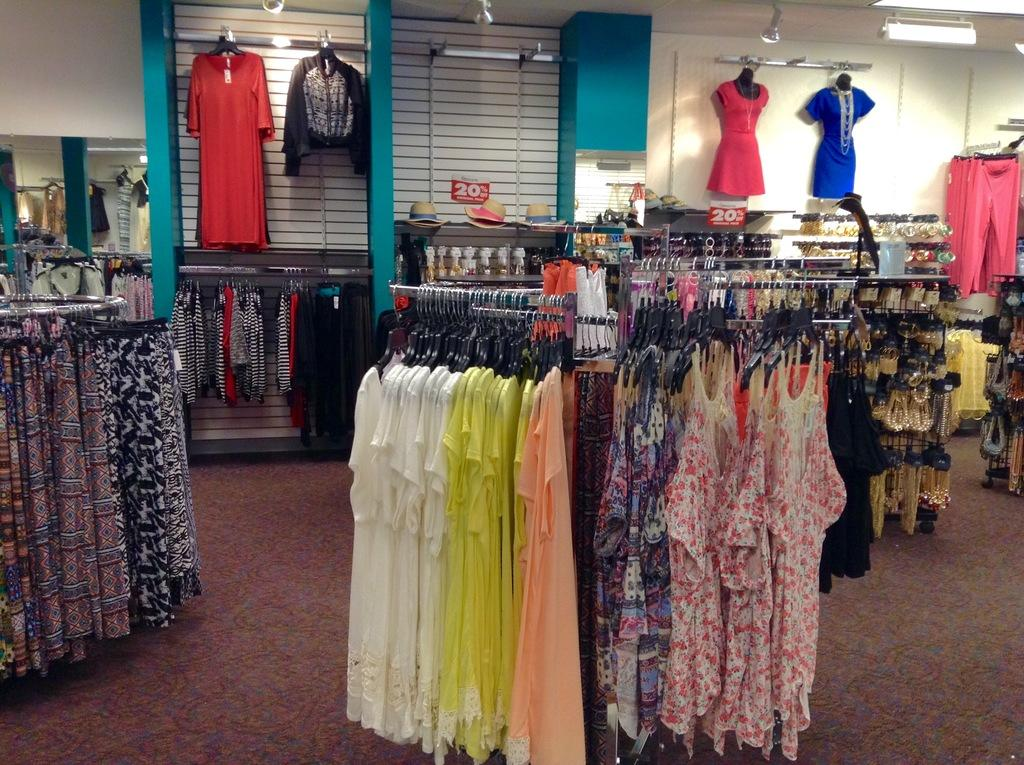What type of store is depicted in the image? The image is of a clothing store. What items can be seen in the store? There are clothes and hats in the image. How can customers determine the price of the items? There are rate tags in the image. What can be seen in the store that provides illumination? There are lights in the image. How do the geese affect the acoustics in the clothing store? There are no geese present in the image, so their impact on the acoustics cannot be determined. 